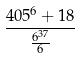Convert formula to latex. <formula><loc_0><loc_0><loc_500><loc_500>\frac { 4 0 5 ^ { 6 } + 1 8 } { \frac { 6 ^ { 3 7 } } { 6 } }</formula> 